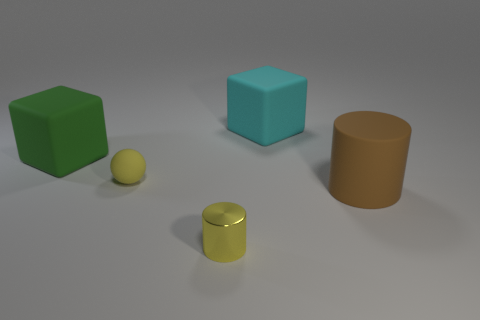Are there any other things that are made of the same material as the yellow cylinder?
Ensure brevity in your answer.  No. Is the size of the yellow rubber ball the same as the yellow cylinder that is in front of the green object?
Your answer should be compact. Yes. What is the size of the yellow metal object right of the matte block in front of the large object behind the green matte thing?
Provide a short and direct response. Small. How many things are either big matte objects in front of the small yellow rubber object or rubber spheres?
Provide a short and direct response. 2. There is a rubber object that is right of the cyan object; how many cyan rubber things are right of it?
Your answer should be compact. 0. Are there more large rubber cubes to the left of the tiny rubber thing than big cylinders?
Ensure brevity in your answer.  No. There is a thing that is to the right of the large green rubber thing and left of the yellow metallic thing; what is its size?
Provide a short and direct response. Small. There is a thing that is in front of the tiny matte object and behind the tiny yellow metallic object; what shape is it?
Your answer should be compact. Cylinder. Is there a matte thing behind the object to the right of the big matte object that is behind the big green rubber cube?
Keep it short and to the point. Yes. What number of things are either cylinders that are to the left of the big cylinder or large cyan blocks on the right side of the tiny metal cylinder?
Keep it short and to the point. 2. 